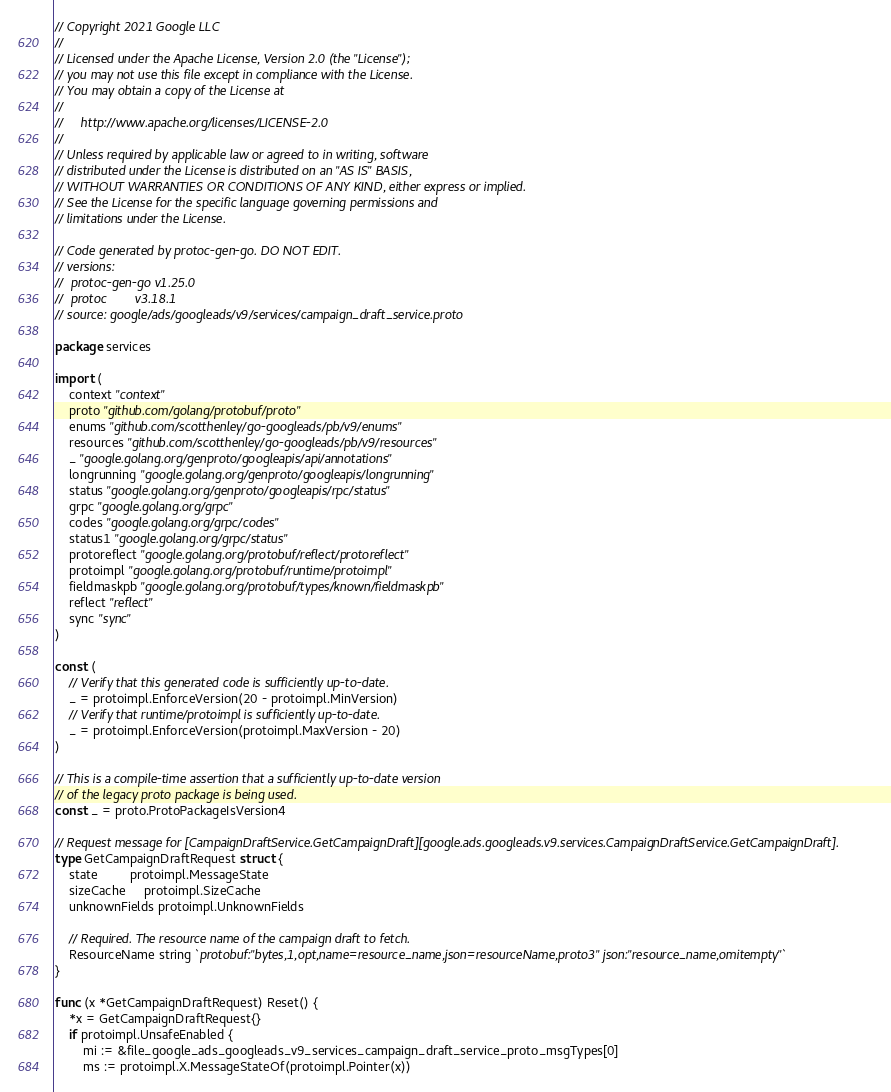<code> <loc_0><loc_0><loc_500><loc_500><_Go_>// Copyright 2021 Google LLC
//
// Licensed under the Apache License, Version 2.0 (the "License");
// you may not use this file except in compliance with the License.
// You may obtain a copy of the License at
//
//     http://www.apache.org/licenses/LICENSE-2.0
//
// Unless required by applicable law or agreed to in writing, software
// distributed under the License is distributed on an "AS IS" BASIS,
// WITHOUT WARRANTIES OR CONDITIONS OF ANY KIND, either express or implied.
// See the License for the specific language governing permissions and
// limitations under the License.

// Code generated by protoc-gen-go. DO NOT EDIT.
// versions:
// 	protoc-gen-go v1.25.0
// 	protoc        v3.18.1
// source: google/ads/googleads/v9/services/campaign_draft_service.proto

package services

import (
	context "context"
	proto "github.com/golang/protobuf/proto"
	enums "github.com/scotthenley/go-googleads/pb/v9/enums"
	resources "github.com/scotthenley/go-googleads/pb/v9/resources"
	_ "google.golang.org/genproto/googleapis/api/annotations"
	longrunning "google.golang.org/genproto/googleapis/longrunning"
	status "google.golang.org/genproto/googleapis/rpc/status"
	grpc "google.golang.org/grpc"
	codes "google.golang.org/grpc/codes"
	status1 "google.golang.org/grpc/status"
	protoreflect "google.golang.org/protobuf/reflect/protoreflect"
	protoimpl "google.golang.org/protobuf/runtime/protoimpl"
	fieldmaskpb "google.golang.org/protobuf/types/known/fieldmaskpb"
	reflect "reflect"
	sync "sync"
)

const (
	// Verify that this generated code is sufficiently up-to-date.
	_ = protoimpl.EnforceVersion(20 - protoimpl.MinVersion)
	// Verify that runtime/protoimpl is sufficiently up-to-date.
	_ = protoimpl.EnforceVersion(protoimpl.MaxVersion - 20)
)

// This is a compile-time assertion that a sufficiently up-to-date version
// of the legacy proto package is being used.
const _ = proto.ProtoPackageIsVersion4

// Request message for [CampaignDraftService.GetCampaignDraft][google.ads.googleads.v9.services.CampaignDraftService.GetCampaignDraft].
type GetCampaignDraftRequest struct {
	state         protoimpl.MessageState
	sizeCache     protoimpl.SizeCache
	unknownFields protoimpl.UnknownFields

	// Required. The resource name of the campaign draft to fetch.
	ResourceName string `protobuf:"bytes,1,opt,name=resource_name,json=resourceName,proto3" json:"resource_name,omitempty"`
}

func (x *GetCampaignDraftRequest) Reset() {
	*x = GetCampaignDraftRequest{}
	if protoimpl.UnsafeEnabled {
		mi := &file_google_ads_googleads_v9_services_campaign_draft_service_proto_msgTypes[0]
		ms := protoimpl.X.MessageStateOf(protoimpl.Pointer(x))</code> 